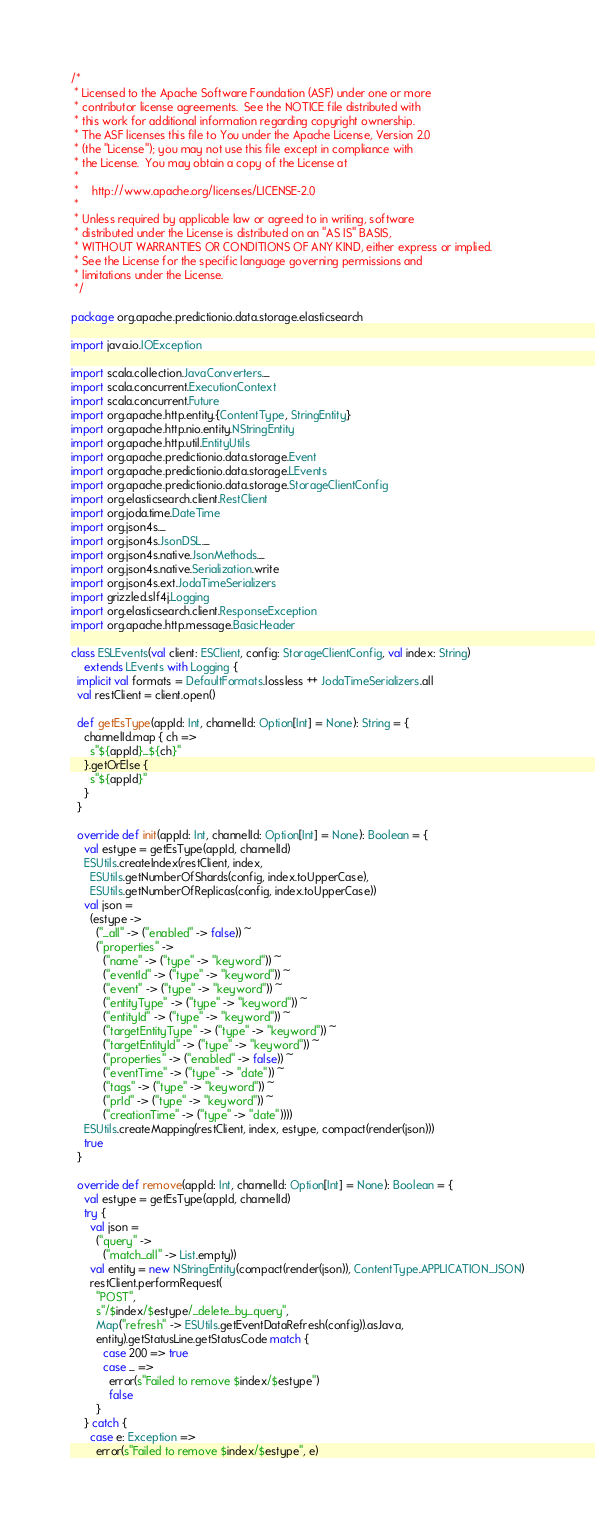<code> <loc_0><loc_0><loc_500><loc_500><_Scala_>/*
 * Licensed to the Apache Software Foundation (ASF) under one or more
 * contributor license agreements.  See the NOTICE file distributed with
 * this work for additional information regarding copyright ownership.
 * The ASF licenses this file to You under the Apache License, Version 2.0
 * (the "License"); you may not use this file except in compliance with
 * the License.  You may obtain a copy of the License at
 *
 *    http://www.apache.org/licenses/LICENSE-2.0
 *
 * Unless required by applicable law or agreed to in writing, software
 * distributed under the License is distributed on an "AS IS" BASIS,
 * WITHOUT WARRANTIES OR CONDITIONS OF ANY KIND, either express or implied.
 * See the License for the specific language governing permissions and
 * limitations under the License.
 */

package org.apache.predictionio.data.storage.elasticsearch

import java.io.IOException

import scala.collection.JavaConverters._
import scala.concurrent.ExecutionContext
import scala.concurrent.Future
import org.apache.http.entity.{ContentType, StringEntity}
import org.apache.http.nio.entity.NStringEntity
import org.apache.http.util.EntityUtils
import org.apache.predictionio.data.storage.Event
import org.apache.predictionio.data.storage.LEvents
import org.apache.predictionio.data.storage.StorageClientConfig
import org.elasticsearch.client.RestClient
import org.joda.time.DateTime
import org.json4s._
import org.json4s.JsonDSL._
import org.json4s.native.JsonMethods._
import org.json4s.native.Serialization.write
import org.json4s.ext.JodaTimeSerializers
import grizzled.slf4j.Logging
import org.elasticsearch.client.ResponseException
import org.apache.http.message.BasicHeader

class ESLEvents(val client: ESClient, config: StorageClientConfig, val index: String)
    extends LEvents with Logging {
  implicit val formats = DefaultFormats.lossless ++ JodaTimeSerializers.all
  val restClient = client.open()

  def getEsType(appId: Int, channelId: Option[Int] = None): String = {
    channelId.map { ch =>
      s"${appId}_${ch}"
    }.getOrElse {
      s"${appId}"
    }
  }

  override def init(appId: Int, channelId: Option[Int] = None): Boolean = {
    val estype = getEsType(appId, channelId)
    ESUtils.createIndex(restClient, index,
      ESUtils.getNumberOfShards(config, index.toUpperCase),
      ESUtils.getNumberOfReplicas(config, index.toUpperCase))
    val json =
      (estype ->
        ("_all" -> ("enabled" -> false)) ~
        ("properties" ->
          ("name" -> ("type" -> "keyword")) ~
          ("eventId" -> ("type" -> "keyword")) ~
          ("event" -> ("type" -> "keyword")) ~
          ("entityType" -> ("type" -> "keyword")) ~
          ("entityId" -> ("type" -> "keyword")) ~
          ("targetEntityType" -> ("type" -> "keyword")) ~
          ("targetEntityId" -> ("type" -> "keyword")) ~
          ("properties" -> ("enabled" -> false)) ~
          ("eventTime" -> ("type" -> "date")) ~
          ("tags" -> ("type" -> "keyword")) ~
          ("prId" -> ("type" -> "keyword")) ~
          ("creationTime" -> ("type" -> "date"))))
    ESUtils.createMapping(restClient, index, estype, compact(render(json)))
    true
  }

  override def remove(appId: Int, channelId: Option[Int] = None): Boolean = {
    val estype = getEsType(appId, channelId)
    try {
      val json =
        ("query" ->
          ("match_all" -> List.empty))
      val entity = new NStringEntity(compact(render(json)), ContentType.APPLICATION_JSON)
      restClient.performRequest(
        "POST",
        s"/$index/$estype/_delete_by_query",
        Map("refresh" -> ESUtils.getEventDataRefresh(config)).asJava,
        entity).getStatusLine.getStatusCode match {
          case 200 => true
          case _ =>
            error(s"Failed to remove $index/$estype")
            false
        }
    } catch {
      case e: Exception =>
        error(s"Failed to remove $index/$estype", e)</code> 